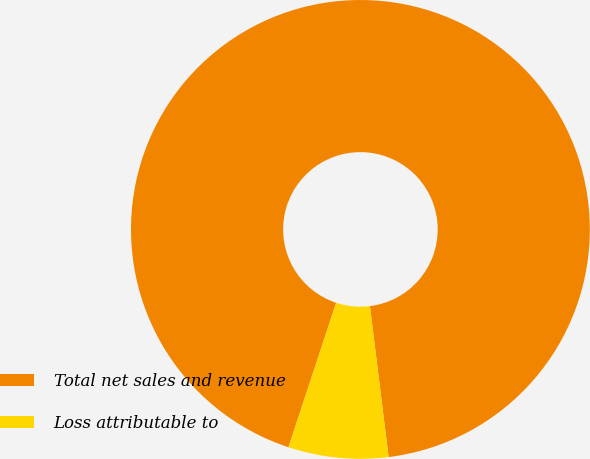Convert chart to OTSL. <chart><loc_0><loc_0><loc_500><loc_500><pie_chart><fcel>Total net sales and revenue<fcel>Loss attributable to<nl><fcel>92.96%<fcel>7.04%<nl></chart> 